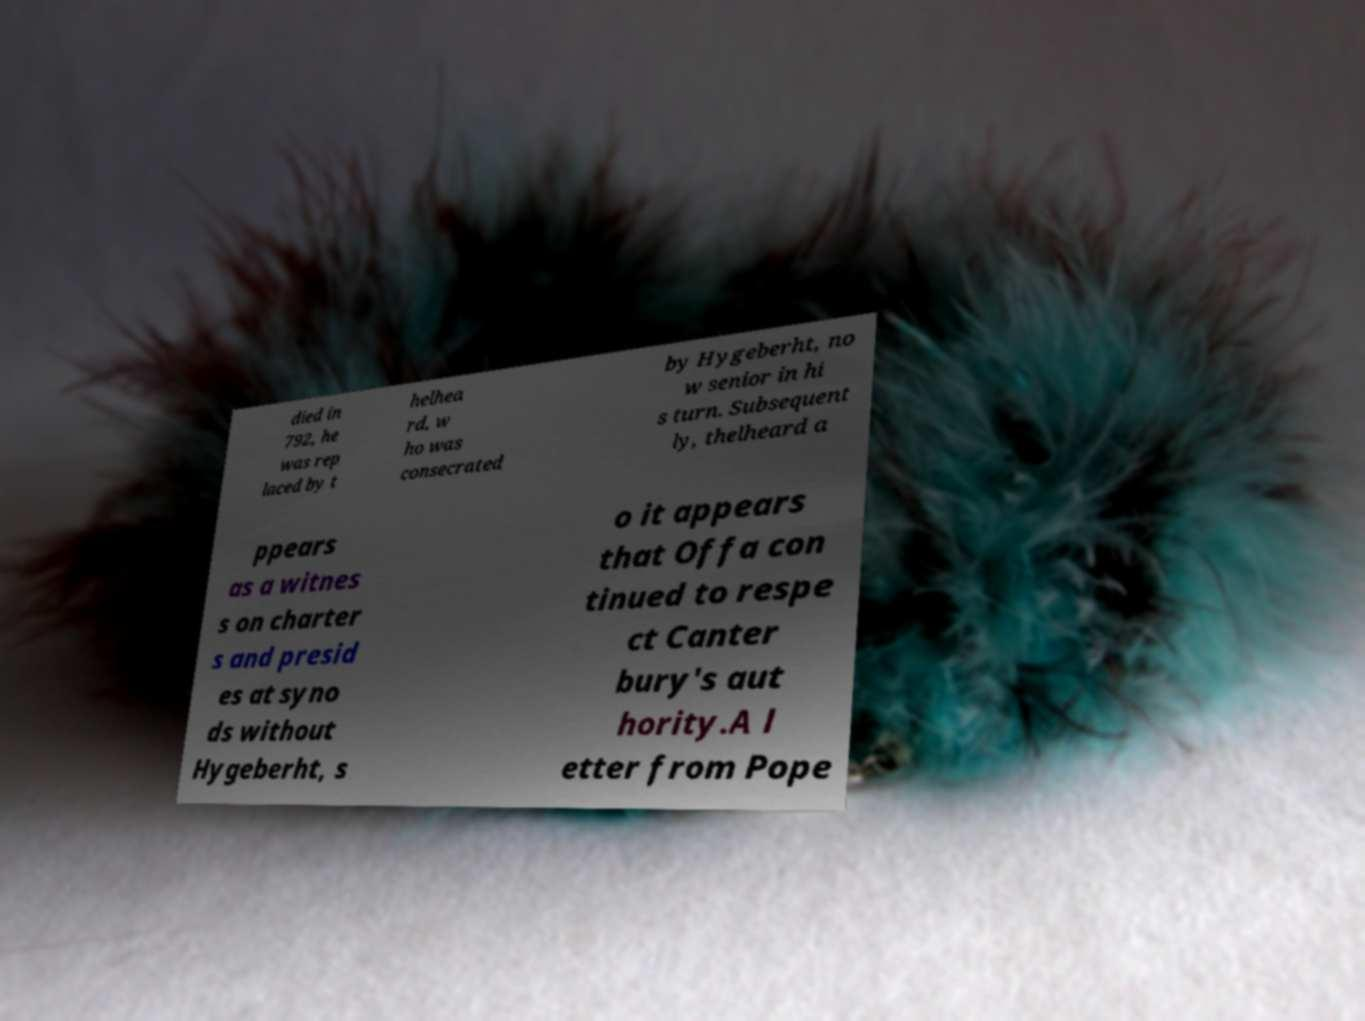Can you accurately transcribe the text from the provided image for me? died in 792, he was rep laced by t helhea rd, w ho was consecrated by Hygeberht, no w senior in hi s turn. Subsequent ly, thelheard a ppears as a witnes s on charter s and presid es at syno ds without Hygeberht, s o it appears that Offa con tinued to respe ct Canter bury's aut hority.A l etter from Pope 